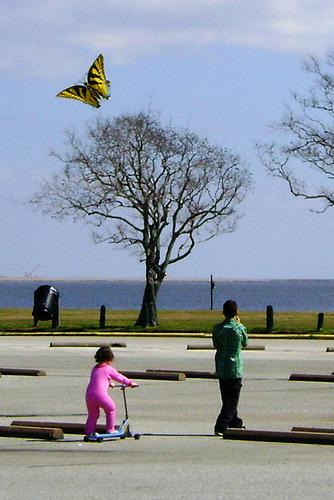The kite here is designed to resemble what?

Choices:
A) butterfly
B) house fly
C) dog
D) bird butterfly 